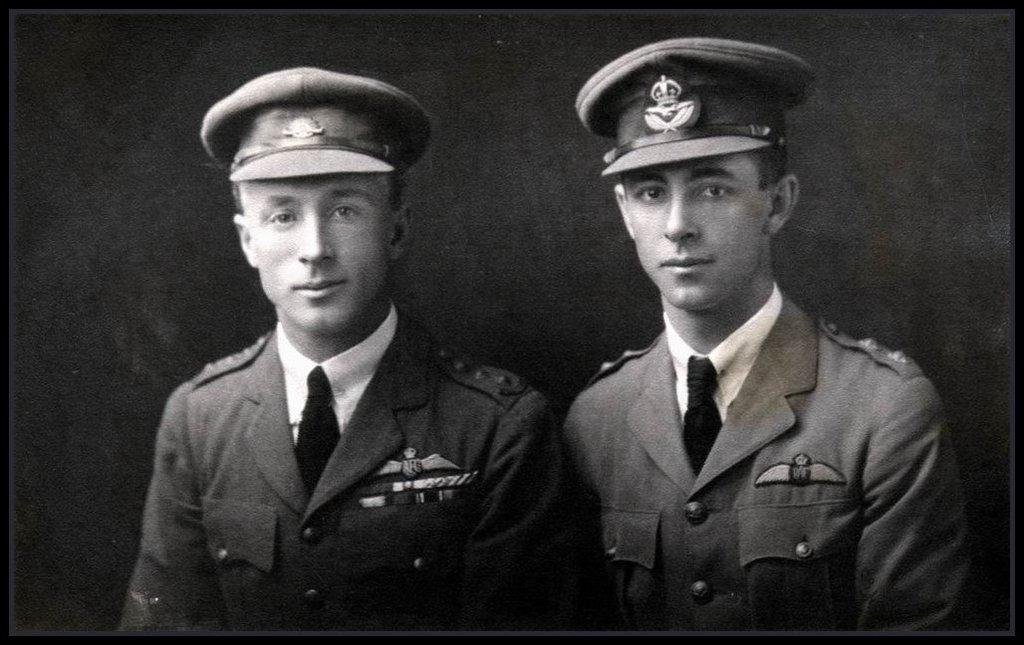How many people are present in the image? There are two men in the image. What can be observed about the background of the image? The background of the image is black in color. What type of substance is the visitor using to create the effect in the image? There is no visitor or effect present in the image; it features two men with a black background. 